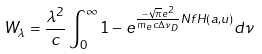<formula> <loc_0><loc_0><loc_500><loc_500>W _ { \lambda } = \frac { \lambda ^ { 2 } } { c } \int ^ { \infty } _ { 0 } 1 - e ^ { \frac { - \sqrt { \pi } e ^ { 2 } } { m _ { e } c \Delta \nu _ { D } } N f H ( a , u ) } d \nu</formula> 